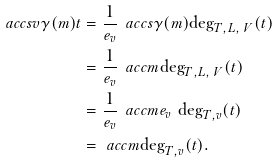Convert formula to latex. <formula><loc_0><loc_0><loc_500><loc_500>\ a c c s v { \gamma ( m ) } { t } & = \frac { 1 } { e _ { v } } \, \ a c c s { \gamma ( m ) } { \deg _ { T , L , \ V } ( t ) } \\ & = \frac { 1 } { e _ { v } } \, \ a c c { m } { \deg _ { T , L , \ V } ( t ) } \\ & = \frac { 1 } { e _ { v } } \, \ a c c { m } { e _ { v } \, \deg _ { T , v } ( t ) } \\ & = \ a c c { m } { \deg _ { T , v } ( t ) } .</formula> 